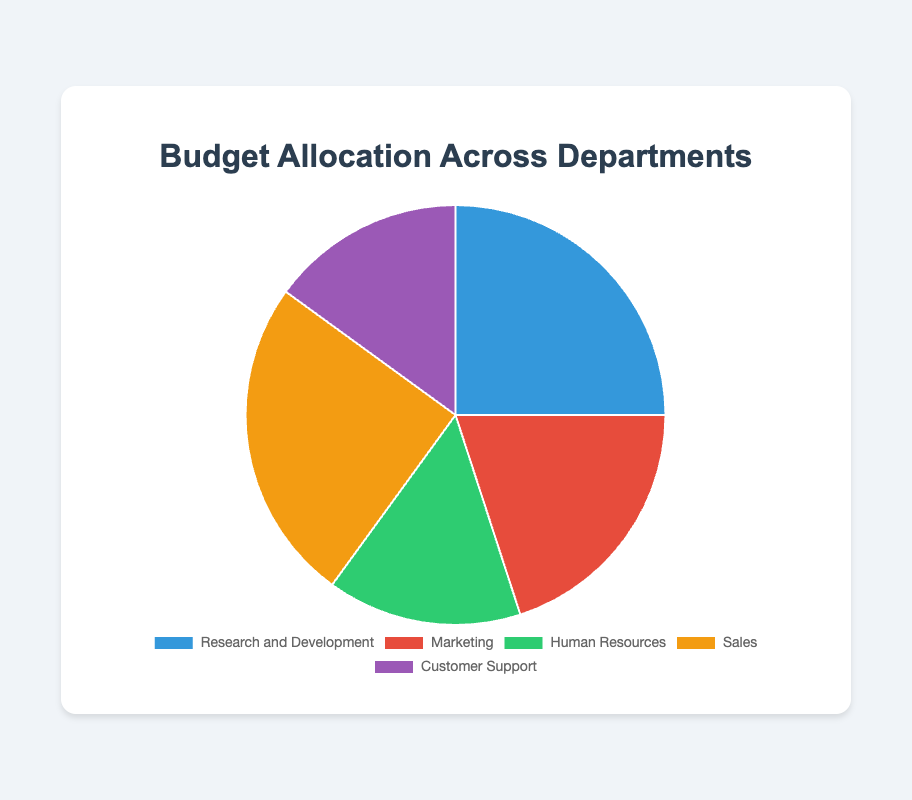What is the total budget percentage allocated to the Sales and Marketing departments? The budget percentage for Sales is 25%, and the budget percentage for Marketing is 20%. Adding these together gives 25% + 20% = 45%.
Answer: 45% Which department has the smallest budget allocation, and what is its percentage? Human Resources and Customer Support both have the smallest budget allocation at 15%.
Answer: Human Resources and Customer Support, 15% What is the difference in budget allocation between Research and Development, and Customer Support? The budget percentage for Research and Development is 25%, and the budget percentage for Customer Support is 15%. The difference is 25% - 15% = 10%.
Answer: 10% Which departments have the same budget percentage, and what is that percentage? Research and Development and Sales both have a budget percentage of 25%. Similarly, Human Resources and Customer Support both have 15%.
Answer: Research and Development and Sales, 25%; Human Resources and Customer Support, 15% How is the budget between Human Resources and Customer Support visually represented in the pie chart, considering the size and color? Both Human Resources and Customer Support take up equal-sized slices of the pie chart and are colored green and purple, respectively.
Answer: Equal-sized, green and purple What percentage of the budget is allocated to departments other than Sales? The total budget percentage is 100%. Subtract the Sales percentage (25%) from 100%, yielding 100% - 25% = 75%.
Answer: 75% How many departments have a budget allocation greater than 15% and what are they? Research and Development (25%), Marketing (20%), and Sales (25%) all have a budget allocation greater than 15%.
Answer: Three departments: Research and Development, Marketing, Sales What is the average budget percentage of all departments? Sum the percentages of all departments: 25% + 20% + 15% + 25% + 15% = 100%. Divide by the number of departments, which is 5. So, 100% / 5 = 20%.
Answer: 20% Comparatively, which department has a higher budget allocation, Marketing or Human Resources? The budget allocation for Marketing is 20%, and for Human Resources, it is 15%. Therefore, Marketing has a higher budget allocation.
Answer: Marketing 